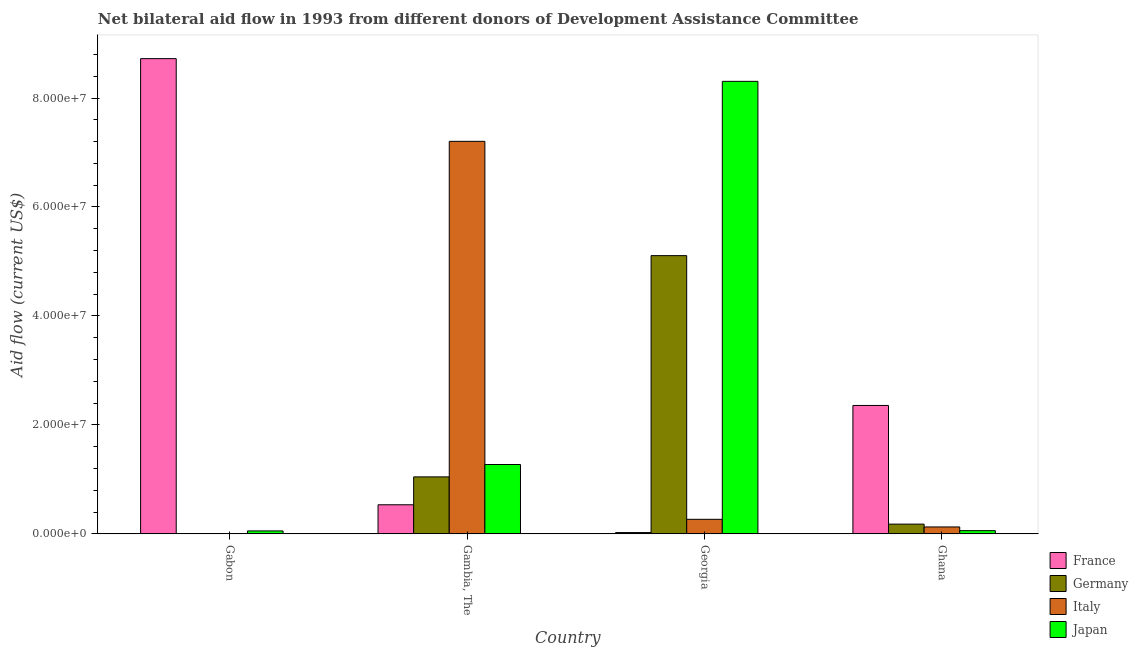Are the number of bars per tick equal to the number of legend labels?
Your answer should be compact. No. Are the number of bars on each tick of the X-axis equal?
Give a very brief answer. No. What is the label of the 1st group of bars from the left?
Your response must be concise. Gabon. What is the amount of aid given by france in Gambia, The?
Your response must be concise. 5.34e+06. Across all countries, what is the maximum amount of aid given by italy?
Provide a succinct answer. 7.20e+07. Across all countries, what is the minimum amount of aid given by germany?
Make the answer very short. 5.00e+04. In which country was the amount of aid given by japan maximum?
Ensure brevity in your answer.  Georgia. What is the total amount of aid given by france in the graph?
Offer a very short reply. 1.16e+08. What is the difference between the amount of aid given by germany in Gabon and that in Gambia, The?
Make the answer very short. -1.04e+07. What is the difference between the amount of aid given by france in Gambia, The and the amount of aid given by germany in Georgia?
Provide a succinct answer. -4.57e+07. What is the average amount of aid given by germany per country?
Provide a succinct answer. 1.58e+07. What is the difference between the amount of aid given by germany and amount of aid given by italy in Georgia?
Your answer should be compact. 4.84e+07. In how many countries, is the amount of aid given by italy greater than 8000000 US$?
Your response must be concise. 1. What is the ratio of the amount of aid given by france in Gabon to that in Ghana?
Offer a terse response. 3.7. Is the amount of aid given by france in Georgia less than that in Ghana?
Offer a very short reply. Yes. Is the difference between the amount of aid given by france in Gambia, The and Ghana greater than the difference between the amount of aid given by italy in Gambia, The and Ghana?
Offer a very short reply. No. What is the difference between the highest and the second highest amount of aid given by japan?
Give a very brief answer. 7.03e+07. What is the difference between the highest and the lowest amount of aid given by italy?
Make the answer very short. 7.20e+07. Are the values on the major ticks of Y-axis written in scientific E-notation?
Your answer should be very brief. Yes. Does the graph contain any zero values?
Ensure brevity in your answer.  Yes. Where does the legend appear in the graph?
Your answer should be very brief. Bottom right. What is the title of the graph?
Keep it short and to the point. Net bilateral aid flow in 1993 from different donors of Development Assistance Committee. Does "Taxes on exports" appear as one of the legend labels in the graph?
Ensure brevity in your answer.  No. What is the label or title of the X-axis?
Keep it short and to the point. Country. What is the label or title of the Y-axis?
Give a very brief answer. Aid flow (current US$). What is the Aid flow (current US$) of France in Gabon?
Offer a terse response. 8.72e+07. What is the Aid flow (current US$) of Japan in Gabon?
Your answer should be compact. 5.40e+05. What is the Aid flow (current US$) of France in Gambia, The?
Provide a succinct answer. 5.34e+06. What is the Aid flow (current US$) of Germany in Gambia, The?
Offer a very short reply. 1.05e+07. What is the Aid flow (current US$) in Italy in Gambia, The?
Make the answer very short. 7.20e+07. What is the Aid flow (current US$) of Japan in Gambia, The?
Provide a short and direct response. 1.27e+07. What is the Aid flow (current US$) of France in Georgia?
Provide a short and direct response. 2.40e+05. What is the Aid flow (current US$) in Germany in Georgia?
Keep it short and to the point. 5.11e+07. What is the Aid flow (current US$) in Italy in Georgia?
Make the answer very short. 2.67e+06. What is the Aid flow (current US$) in Japan in Georgia?
Offer a terse response. 8.31e+07. What is the Aid flow (current US$) of France in Ghana?
Your answer should be very brief. 2.36e+07. What is the Aid flow (current US$) in Germany in Ghana?
Your response must be concise. 1.79e+06. What is the Aid flow (current US$) in Italy in Ghana?
Offer a very short reply. 1.27e+06. What is the Aid flow (current US$) of Japan in Ghana?
Give a very brief answer. 5.90e+05. Across all countries, what is the maximum Aid flow (current US$) in France?
Make the answer very short. 8.72e+07. Across all countries, what is the maximum Aid flow (current US$) of Germany?
Your response must be concise. 5.11e+07. Across all countries, what is the maximum Aid flow (current US$) in Italy?
Give a very brief answer. 7.20e+07. Across all countries, what is the maximum Aid flow (current US$) in Japan?
Make the answer very short. 8.31e+07. Across all countries, what is the minimum Aid flow (current US$) in France?
Provide a succinct answer. 2.40e+05. Across all countries, what is the minimum Aid flow (current US$) of Germany?
Give a very brief answer. 5.00e+04. Across all countries, what is the minimum Aid flow (current US$) in Japan?
Your response must be concise. 5.40e+05. What is the total Aid flow (current US$) of France in the graph?
Provide a short and direct response. 1.16e+08. What is the total Aid flow (current US$) of Germany in the graph?
Your response must be concise. 6.34e+07. What is the total Aid flow (current US$) in Italy in the graph?
Your response must be concise. 7.60e+07. What is the total Aid flow (current US$) in Japan in the graph?
Your answer should be very brief. 9.69e+07. What is the difference between the Aid flow (current US$) in France in Gabon and that in Gambia, The?
Your answer should be compact. 8.19e+07. What is the difference between the Aid flow (current US$) in Germany in Gabon and that in Gambia, The?
Make the answer very short. -1.04e+07. What is the difference between the Aid flow (current US$) in Japan in Gabon and that in Gambia, The?
Ensure brevity in your answer.  -1.22e+07. What is the difference between the Aid flow (current US$) of France in Gabon and that in Georgia?
Your answer should be compact. 8.70e+07. What is the difference between the Aid flow (current US$) in Germany in Gabon and that in Georgia?
Make the answer very short. -5.10e+07. What is the difference between the Aid flow (current US$) in Japan in Gabon and that in Georgia?
Provide a succinct answer. -8.25e+07. What is the difference between the Aid flow (current US$) in France in Gabon and that in Ghana?
Your answer should be very brief. 6.37e+07. What is the difference between the Aid flow (current US$) of Germany in Gabon and that in Ghana?
Your response must be concise. -1.74e+06. What is the difference between the Aid flow (current US$) of France in Gambia, The and that in Georgia?
Provide a succinct answer. 5.10e+06. What is the difference between the Aid flow (current US$) in Germany in Gambia, The and that in Georgia?
Keep it short and to the point. -4.06e+07. What is the difference between the Aid flow (current US$) in Italy in Gambia, The and that in Georgia?
Your response must be concise. 6.94e+07. What is the difference between the Aid flow (current US$) in Japan in Gambia, The and that in Georgia?
Your answer should be very brief. -7.03e+07. What is the difference between the Aid flow (current US$) of France in Gambia, The and that in Ghana?
Provide a short and direct response. -1.82e+07. What is the difference between the Aid flow (current US$) of Germany in Gambia, The and that in Ghana?
Provide a succinct answer. 8.67e+06. What is the difference between the Aid flow (current US$) in Italy in Gambia, The and that in Ghana?
Ensure brevity in your answer.  7.08e+07. What is the difference between the Aid flow (current US$) in Japan in Gambia, The and that in Ghana?
Offer a very short reply. 1.21e+07. What is the difference between the Aid flow (current US$) of France in Georgia and that in Ghana?
Give a very brief answer. -2.33e+07. What is the difference between the Aid flow (current US$) in Germany in Georgia and that in Ghana?
Offer a very short reply. 4.93e+07. What is the difference between the Aid flow (current US$) of Italy in Georgia and that in Ghana?
Provide a short and direct response. 1.40e+06. What is the difference between the Aid flow (current US$) of Japan in Georgia and that in Ghana?
Your answer should be very brief. 8.25e+07. What is the difference between the Aid flow (current US$) in France in Gabon and the Aid flow (current US$) in Germany in Gambia, The?
Ensure brevity in your answer.  7.68e+07. What is the difference between the Aid flow (current US$) of France in Gabon and the Aid flow (current US$) of Italy in Gambia, The?
Offer a terse response. 1.52e+07. What is the difference between the Aid flow (current US$) of France in Gabon and the Aid flow (current US$) of Japan in Gambia, The?
Your answer should be compact. 7.45e+07. What is the difference between the Aid flow (current US$) in Germany in Gabon and the Aid flow (current US$) in Italy in Gambia, The?
Your answer should be very brief. -7.20e+07. What is the difference between the Aid flow (current US$) in Germany in Gabon and the Aid flow (current US$) in Japan in Gambia, The?
Ensure brevity in your answer.  -1.27e+07. What is the difference between the Aid flow (current US$) in France in Gabon and the Aid flow (current US$) in Germany in Georgia?
Offer a terse response. 3.62e+07. What is the difference between the Aid flow (current US$) in France in Gabon and the Aid flow (current US$) in Italy in Georgia?
Ensure brevity in your answer.  8.46e+07. What is the difference between the Aid flow (current US$) of France in Gabon and the Aid flow (current US$) of Japan in Georgia?
Offer a very short reply. 4.17e+06. What is the difference between the Aid flow (current US$) of Germany in Gabon and the Aid flow (current US$) of Italy in Georgia?
Your response must be concise. -2.62e+06. What is the difference between the Aid flow (current US$) of Germany in Gabon and the Aid flow (current US$) of Japan in Georgia?
Your answer should be compact. -8.30e+07. What is the difference between the Aid flow (current US$) in France in Gabon and the Aid flow (current US$) in Germany in Ghana?
Offer a terse response. 8.54e+07. What is the difference between the Aid flow (current US$) of France in Gabon and the Aid flow (current US$) of Italy in Ghana?
Your response must be concise. 8.60e+07. What is the difference between the Aid flow (current US$) of France in Gabon and the Aid flow (current US$) of Japan in Ghana?
Provide a succinct answer. 8.66e+07. What is the difference between the Aid flow (current US$) in Germany in Gabon and the Aid flow (current US$) in Italy in Ghana?
Your answer should be very brief. -1.22e+06. What is the difference between the Aid flow (current US$) in Germany in Gabon and the Aid flow (current US$) in Japan in Ghana?
Keep it short and to the point. -5.40e+05. What is the difference between the Aid flow (current US$) in France in Gambia, The and the Aid flow (current US$) in Germany in Georgia?
Offer a very short reply. -4.57e+07. What is the difference between the Aid flow (current US$) in France in Gambia, The and the Aid flow (current US$) in Italy in Georgia?
Provide a short and direct response. 2.67e+06. What is the difference between the Aid flow (current US$) of France in Gambia, The and the Aid flow (current US$) of Japan in Georgia?
Provide a short and direct response. -7.77e+07. What is the difference between the Aid flow (current US$) in Germany in Gambia, The and the Aid flow (current US$) in Italy in Georgia?
Provide a short and direct response. 7.79e+06. What is the difference between the Aid flow (current US$) of Germany in Gambia, The and the Aid flow (current US$) of Japan in Georgia?
Keep it short and to the point. -7.26e+07. What is the difference between the Aid flow (current US$) in Italy in Gambia, The and the Aid flow (current US$) in Japan in Georgia?
Give a very brief answer. -1.10e+07. What is the difference between the Aid flow (current US$) in France in Gambia, The and the Aid flow (current US$) in Germany in Ghana?
Your response must be concise. 3.55e+06. What is the difference between the Aid flow (current US$) in France in Gambia, The and the Aid flow (current US$) in Italy in Ghana?
Offer a terse response. 4.07e+06. What is the difference between the Aid flow (current US$) of France in Gambia, The and the Aid flow (current US$) of Japan in Ghana?
Give a very brief answer. 4.75e+06. What is the difference between the Aid flow (current US$) of Germany in Gambia, The and the Aid flow (current US$) of Italy in Ghana?
Your response must be concise. 9.19e+06. What is the difference between the Aid flow (current US$) of Germany in Gambia, The and the Aid flow (current US$) of Japan in Ghana?
Make the answer very short. 9.87e+06. What is the difference between the Aid flow (current US$) in Italy in Gambia, The and the Aid flow (current US$) in Japan in Ghana?
Offer a terse response. 7.15e+07. What is the difference between the Aid flow (current US$) in France in Georgia and the Aid flow (current US$) in Germany in Ghana?
Provide a succinct answer. -1.55e+06. What is the difference between the Aid flow (current US$) of France in Georgia and the Aid flow (current US$) of Italy in Ghana?
Offer a very short reply. -1.03e+06. What is the difference between the Aid flow (current US$) in France in Georgia and the Aid flow (current US$) in Japan in Ghana?
Provide a short and direct response. -3.50e+05. What is the difference between the Aid flow (current US$) of Germany in Georgia and the Aid flow (current US$) of Italy in Ghana?
Give a very brief answer. 4.98e+07. What is the difference between the Aid flow (current US$) in Germany in Georgia and the Aid flow (current US$) in Japan in Ghana?
Provide a succinct answer. 5.05e+07. What is the difference between the Aid flow (current US$) in Italy in Georgia and the Aid flow (current US$) in Japan in Ghana?
Your answer should be very brief. 2.08e+06. What is the average Aid flow (current US$) of France per country?
Keep it short and to the point. 2.91e+07. What is the average Aid flow (current US$) of Germany per country?
Give a very brief answer. 1.58e+07. What is the average Aid flow (current US$) in Italy per country?
Offer a terse response. 1.90e+07. What is the average Aid flow (current US$) in Japan per country?
Give a very brief answer. 2.42e+07. What is the difference between the Aid flow (current US$) of France and Aid flow (current US$) of Germany in Gabon?
Offer a very short reply. 8.72e+07. What is the difference between the Aid flow (current US$) of France and Aid flow (current US$) of Japan in Gabon?
Provide a short and direct response. 8.67e+07. What is the difference between the Aid flow (current US$) in Germany and Aid flow (current US$) in Japan in Gabon?
Provide a succinct answer. -4.90e+05. What is the difference between the Aid flow (current US$) of France and Aid flow (current US$) of Germany in Gambia, The?
Your answer should be very brief. -5.12e+06. What is the difference between the Aid flow (current US$) in France and Aid flow (current US$) in Italy in Gambia, The?
Provide a succinct answer. -6.67e+07. What is the difference between the Aid flow (current US$) in France and Aid flow (current US$) in Japan in Gambia, The?
Keep it short and to the point. -7.39e+06. What is the difference between the Aid flow (current US$) in Germany and Aid flow (current US$) in Italy in Gambia, The?
Offer a terse response. -6.16e+07. What is the difference between the Aid flow (current US$) of Germany and Aid flow (current US$) of Japan in Gambia, The?
Offer a very short reply. -2.27e+06. What is the difference between the Aid flow (current US$) in Italy and Aid flow (current US$) in Japan in Gambia, The?
Provide a short and direct response. 5.93e+07. What is the difference between the Aid flow (current US$) in France and Aid flow (current US$) in Germany in Georgia?
Provide a short and direct response. -5.08e+07. What is the difference between the Aid flow (current US$) in France and Aid flow (current US$) in Italy in Georgia?
Keep it short and to the point. -2.43e+06. What is the difference between the Aid flow (current US$) in France and Aid flow (current US$) in Japan in Georgia?
Provide a short and direct response. -8.28e+07. What is the difference between the Aid flow (current US$) of Germany and Aid flow (current US$) of Italy in Georgia?
Offer a very short reply. 4.84e+07. What is the difference between the Aid flow (current US$) in Germany and Aid flow (current US$) in Japan in Georgia?
Your answer should be compact. -3.20e+07. What is the difference between the Aid flow (current US$) in Italy and Aid flow (current US$) in Japan in Georgia?
Offer a very short reply. -8.04e+07. What is the difference between the Aid flow (current US$) in France and Aid flow (current US$) in Germany in Ghana?
Give a very brief answer. 2.18e+07. What is the difference between the Aid flow (current US$) in France and Aid flow (current US$) in Italy in Ghana?
Your answer should be very brief. 2.23e+07. What is the difference between the Aid flow (current US$) in France and Aid flow (current US$) in Japan in Ghana?
Offer a very short reply. 2.30e+07. What is the difference between the Aid flow (current US$) of Germany and Aid flow (current US$) of Italy in Ghana?
Keep it short and to the point. 5.20e+05. What is the difference between the Aid flow (current US$) in Germany and Aid flow (current US$) in Japan in Ghana?
Ensure brevity in your answer.  1.20e+06. What is the difference between the Aid flow (current US$) in Italy and Aid flow (current US$) in Japan in Ghana?
Provide a succinct answer. 6.80e+05. What is the ratio of the Aid flow (current US$) of France in Gabon to that in Gambia, The?
Your answer should be very brief. 16.34. What is the ratio of the Aid flow (current US$) of Germany in Gabon to that in Gambia, The?
Provide a succinct answer. 0. What is the ratio of the Aid flow (current US$) of Japan in Gabon to that in Gambia, The?
Provide a short and direct response. 0.04. What is the ratio of the Aid flow (current US$) of France in Gabon to that in Georgia?
Keep it short and to the point. 363.46. What is the ratio of the Aid flow (current US$) of Japan in Gabon to that in Georgia?
Provide a short and direct response. 0.01. What is the ratio of the Aid flow (current US$) of France in Gabon to that in Ghana?
Offer a terse response. 3.7. What is the ratio of the Aid flow (current US$) in Germany in Gabon to that in Ghana?
Offer a very short reply. 0.03. What is the ratio of the Aid flow (current US$) of Japan in Gabon to that in Ghana?
Keep it short and to the point. 0.92. What is the ratio of the Aid flow (current US$) of France in Gambia, The to that in Georgia?
Give a very brief answer. 22.25. What is the ratio of the Aid flow (current US$) of Germany in Gambia, The to that in Georgia?
Your response must be concise. 0.2. What is the ratio of the Aid flow (current US$) in Italy in Gambia, The to that in Georgia?
Give a very brief answer. 26.98. What is the ratio of the Aid flow (current US$) of Japan in Gambia, The to that in Georgia?
Provide a short and direct response. 0.15. What is the ratio of the Aid flow (current US$) of France in Gambia, The to that in Ghana?
Make the answer very short. 0.23. What is the ratio of the Aid flow (current US$) of Germany in Gambia, The to that in Ghana?
Make the answer very short. 5.84. What is the ratio of the Aid flow (current US$) in Italy in Gambia, The to that in Ghana?
Make the answer very short. 56.73. What is the ratio of the Aid flow (current US$) in Japan in Gambia, The to that in Ghana?
Provide a short and direct response. 21.58. What is the ratio of the Aid flow (current US$) of France in Georgia to that in Ghana?
Your answer should be compact. 0.01. What is the ratio of the Aid flow (current US$) of Germany in Georgia to that in Ghana?
Give a very brief answer. 28.53. What is the ratio of the Aid flow (current US$) of Italy in Georgia to that in Ghana?
Offer a terse response. 2.1. What is the ratio of the Aid flow (current US$) in Japan in Georgia to that in Ghana?
Your answer should be very brief. 140.78. What is the difference between the highest and the second highest Aid flow (current US$) in France?
Your answer should be compact. 6.37e+07. What is the difference between the highest and the second highest Aid flow (current US$) in Germany?
Ensure brevity in your answer.  4.06e+07. What is the difference between the highest and the second highest Aid flow (current US$) of Italy?
Your response must be concise. 6.94e+07. What is the difference between the highest and the second highest Aid flow (current US$) of Japan?
Provide a short and direct response. 7.03e+07. What is the difference between the highest and the lowest Aid flow (current US$) of France?
Make the answer very short. 8.70e+07. What is the difference between the highest and the lowest Aid flow (current US$) in Germany?
Provide a succinct answer. 5.10e+07. What is the difference between the highest and the lowest Aid flow (current US$) of Italy?
Ensure brevity in your answer.  7.20e+07. What is the difference between the highest and the lowest Aid flow (current US$) in Japan?
Give a very brief answer. 8.25e+07. 